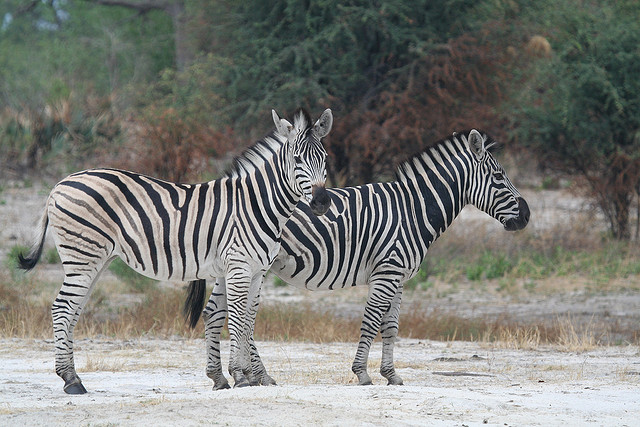<image>Are the zebras hungry? It is unknown if the zebras are hungry. Are the zebras hungry? I don't know if the zebras are hungry. It can be both yes and no. 